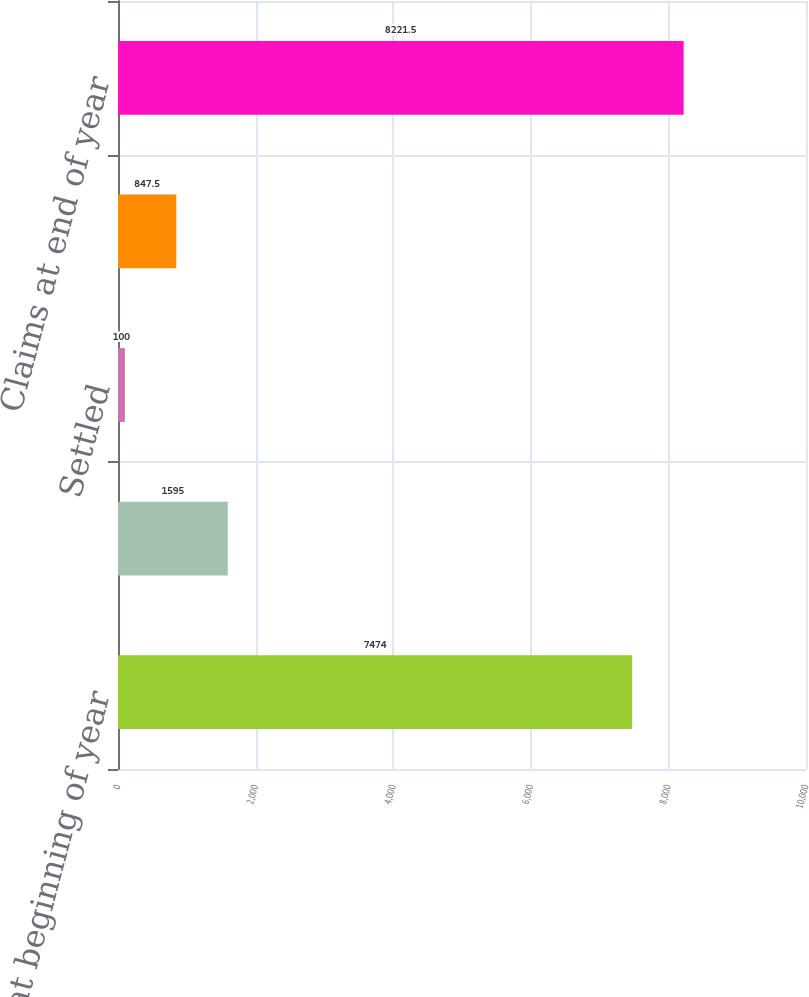Convert chart. <chart><loc_0><loc_0><loc_500><loc_500><bar_chart><fcel>Claims at beginning of year<fcel>Opened<fcel>Settled<fcel>Dismissed or otherwise<fcel>Claims at end of year<nl><fcel>7474<fcel>1595<fcel>100<fcel>847.5<fcel>8221.5<nl></chart> 